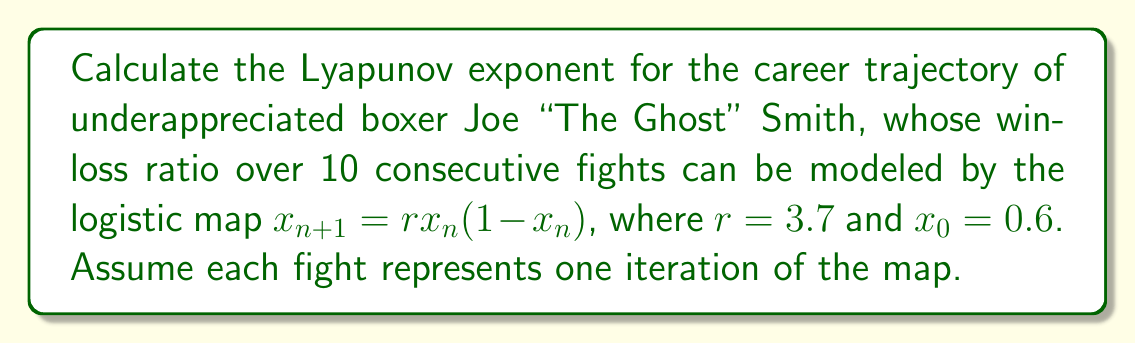Show me your answer to this math problem. To determine the Lyapunov exponent for Joe Smith's career trajectory:

1. The Lyapunov exponent $\lambda$ for the logistic map is given by:

   $$\lambda = \lim_{n\to\infty} \frac{1}{n} \sum_{i=0}^{n-1} \ln|f'(x_i)|$$

   where $f'(x) = r(1-2x)$ for the logistic map.

2. Calculate the first 10 iterations of the map:
   $x_0 = 0.6$
   $x_1 = 3.7 * 0.6 * (1-0.6) = 0.888$
   $x_2 = 3.7 * 0.888 * (1-0.888) = 0.368$
   ...
   $x_9 = 0.843$

3. Calculate $|f'(x_i)|$ for each iteration:
   $|f'(x_0)| = |3.7(1-2*0.6)| = 0.74$
   $|f'(x_1)| = |3.7(1-2*0.888)| = 2.885$
   ...
   $|f'(x_9)| = |3.7(1-2*0.843)| = 2.309$

4. Sum the natural logarithms of these values:
   $$\sum_{i=0}^{9} \ln|f'(x_i)| = -0.301 + 1.059 + ... + 0.837 = 9.845$$

5. Divide by the number of iterations (10) to get the Lyapunov exponent:
   $$\lambda \approx \frac{9.845}{10} = 0.9845$$

This positive Lyapunov exponent indicates chaotic behavior in Joe Smith's career trajectory, suggesting unpredictability in his performance from fight to fight.
Answer: $\lambda \approx 0.9845$ 